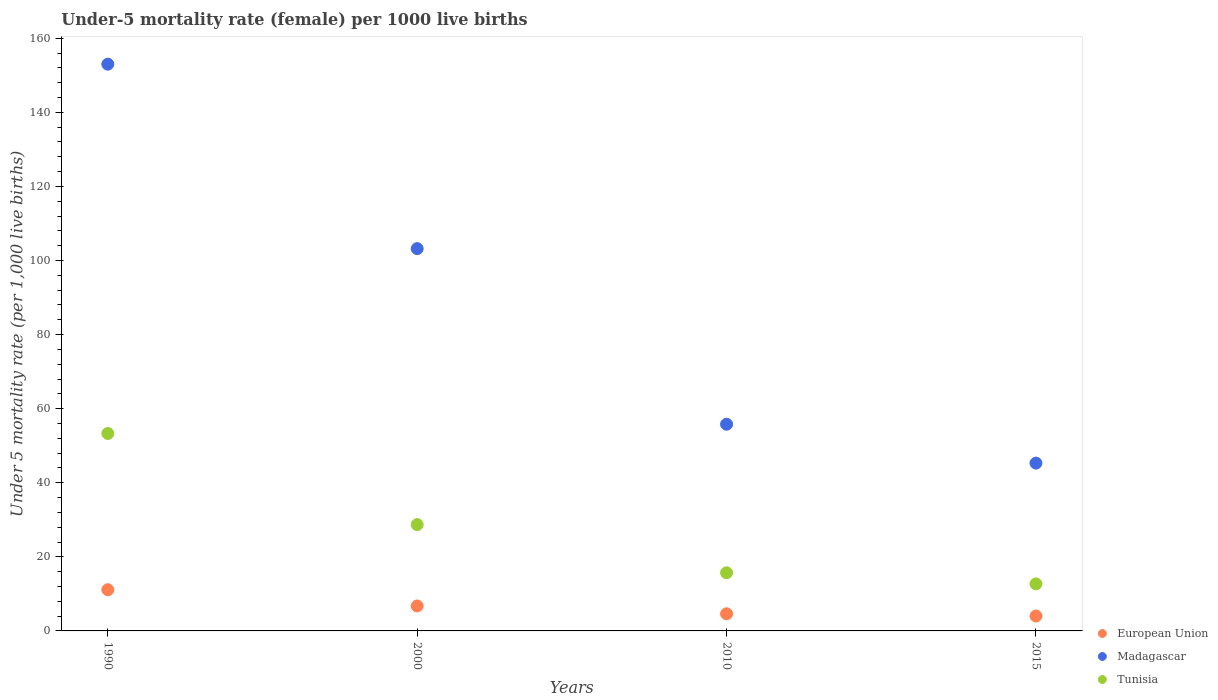What is the under-five mortality rate in Tunisia in 2010?
Offer a very short reply. 15.7. Across all years, what is the maximum under-five mortality rate in Tunisia?
Offer a terse response. 53.3. Across all years, what is the minimum under-five mortality rate in European Union?
Provide a short and direct response. 4.02. In which year was the under-five mortality rate in European Union minimum?
Keep it short and to the point. 2015. What is the total under-five mortality rate in European Union in the graph?
Your answer should be very brief. 26.5. What is the difference between the under-five mortality rate in Tunisia in 2010 and that in 2015?
Your answer should be compact. 3. What is the difference between the under-five mortality rate in European Union in 2000 and the under-five mortality rate in Tunisia in 1990?
Offer a very short reply. -46.57. What is the average under-five mortality rate in European Union per year?
Offer a very short reply. 6.62. In the year 1990, what is the difference between the under-five mortality rate in Madagascar and under-five mortality rate in Tunisia?
Ensure brevity in your answer.  99.7. What is the ratio of the under-five mortality rate in Madagascar in 1990 to that in 2015?
Keep it short and to the point. 3.38. What is the difference between the highest and the second highest under-five mortality rate in Madagascar?
Your answer should be very brief. 49.8. What is the difference between the highest and the lowest under-five mortality rate in Tunisia?
Make the answer very short. 40.6. Is the sum of the under-five mortality rate in Tunisia in 2000 and 2015 greater than the maximum under-five mortality rate in European Union across all years?
Provide a short and direct response. Yes. Is the under-five mortality rate in Madagascar strictly greater than the under-five mortality rate in Tunisia over the years?
Your response must be concise. Yes. How many dotlines are there?
Offer a very short reply. 3. How many years are there in the graph?
Make the answer very short. 4. What is the difference between two consecutive major ticks on the Y-axis?
Offer a very short reply. 20. Does the graph contain any zero values?
Ensure brevity in your answer.  No. Does the graph contain grids?
Your answer should be very brief. No. How many legend labels are there?
Offer a terse response. 3. What is the title of the graph?
Make the answer very short. Under-5 mortality rate (female) per 1000 live births. What is the label or title of the Y-axis?
Provide a succinct answer. Under 5 mortality rate (per 1,0 live births). What is the Under 5 mortality rate (per 1,000 live births) in European Union in 1990?
Offer a very short reply. 11.12. What is the Under 5 mortality rate (per 1,000 live births) in Madagascar in 1990?
Provide a short and direct response. 153. What is the Under 5 mortality rate (per 1,000 live births) of Tunisia in 1990?
Keep it short and to the point. 53.3. What is the Under 5 mortality rate (per 1,000 live births) of European Union in 2000?
Your response must be concise. 6.73. What is the Under 5 mortality rate (per 1,000 live births) in Madagascar in 2000?
Your response must be concise. 103.2. What is the Under 5 mortality rate (per 1,000 live births) of Tunisia in 2000?
Provide a succinct answer. 28.7. What is the Under 5 mortality rate (per 1,000 live births) of European Union in 2010?
Your response must be concise. 4.62. What is the Under 5 mortality rate (per 1,000 live births) in Madagascar in 2010?
Offer a terse response. 55.8. What is the Under 5 mortality rate (per 1,000 live births) of European Union in 2015?
Your response must be concise. 4.02. What is the Under 5 mortality rate (per 1,000 live births) in Madagascar in 2015?
Offer a very short reply. 45.3. Across all years, what is the maximum Under 5 mortality rate (per 1,000 live births) in European Union?
Provide a succinct answer. 11.12. Across all years, what is the maximum Under 5 mortality rate (per 1,000 live births) in Madagascar?
Your response must be concise. 153. Across all years, what is the maximum Under 5 mortality rate (per 1,000 live births) of Tunisia?
Your response must be concise. 53.3. Across all years, what is the minimum Under 5 mortality rate (per 1,000 live births) of European Union?
Ensure brevity in your answer.  4.02. Across all years, what is the minimum Under 5 mortality rate (per 1,000 live births) of Madagascar?
Provide a succinct answer. 45.3. Across all years, what is the minimum Under 5 mortality rate (per 1,000 live births) of Tunisia?
Your answer should be compact. 12.7. What is the total Under 5 mortality rate (per 1,000 live births) in European Union in the graph?
Offer a terse response. 26.5. What is the total Under 5 mortality rate (per 1,000 live births) of Madagascar in the graph?
Make the answer very short. 357.3. What is the total Under 5 mortality rate (per 1,000 live births) in Tunisia in the graph?
Give a very brief answer. 110.4. What is the difference between the Under 5 mortality rate (per 1,000 live births) in European Union in 1990 and that in 2000?
Your answer should be very brief. 4.38. What is the difference between the Under 5 mortality rate (per 1,000 live births) of Madagascar in 1990 and that in 2000?
Give a very brief answer. 49.8. What is the difference between the Under 5 mortality rate (per 1,000 live births) in Tunisia in 1990 and that in 2000?
Provide a succinct answer. 24.6. What is the difference between the Under 5 mortality rate (per 1,000 live births) of European Union in 1990 and that in 2010?
Give a very brief answer. 6.49. What is the difference between the Under 5 mortality rate (per 1,000 live births) of Madagascar in 1990 and that in 2010?
Your answer should be very brief. 97.2. What is the difference between the Under 5 mortality rate (per 1,000 live births) of Tunisia in 1990 and that in 2010?
Offer a very short reply. 37.6. What is the difference between the Under 5 mortality rate (per 1,000 live births) in European Union in 1990 and that in 2015?
Ensure brevity in your answer.  7.1. What is the difference between the Under 5 mortality rate (per 1,000 live births) of Madagascar in 1990 and that in 2015?
Ensure brevity in your answer.  107.7. What is the difference between the Under 5 mortality rate (per 1,000 live births) in Tunisia in 1990 and that in 2015?
Your answer should be compact. 40.6. What is the difference between the Under 5 mortality rate (per 1,000 live births) in European Union in 2000 and that in 2010?
Give a very brief answer. 2.11. What is the difference between the Under 5 mortality rate (per 1,000 live births) in Madagascar in 2000 and that in 2010?
Give a very brief answer. 47.4. What is the difference between the Under 5 mortality rate (per 1,000 live births) of European Union in 2000 and that in 2015?
Offer a very short reply. 2.71. What is the difference between the Under 5 mortality rate (per 1,000 live births) in Madagascar in 2000 and that in 2015?
Your answer should be compact. 57.9. What is the difference between the Under 5 mortality rate (per 1,000 live births) of Tunisia in 2000 and that in 2015?
Give a very brief answer. 16. What is the difference between the Under 5 mortality rate (per 1,000 live births) of European Union in 2010 and that in 2015?
Offer a very short reply. 0.6. What is the difference between the Under 5 mortality rate (per 1,000 live births) of Tunisia in 2010 and that in 2015?
Your response must be concise. 3. What is the difference between the Under 5 mortality rate (per 1,000 live births) in European Union in 1990 and the Under 5 mortality rate (per 1,000 live births) in Madagascar in 2000?
Your answer should be very brief. -92.08. What is the difference between the Under 5 mortality rate (per 1,000 live births) in European Union in 1990 and the Under 5 mortality rate (per 1,000 live births) in Tunisia in 2000?
Your answer should be compact. -17.58. What is the difference between the Under 5 mortality rate (per 1,000 live births) in Madagascar in 1990 and the Under 5 mortality rate (per 1,000 live births) in Tunisia in 2000?
Keep it short and to the point. 124.3. What is the difference between the Under 5 mortality rate (per 1,000 live births) in European Union in 1990 and the Under 5 mortality rate (per 1,000 live births) in Madagascar in 2010?
Your answer should be compact. -44.68. What is the difference between the Under 5 mortality rate (per 1,000 live births) in European Union in 1990 and the Under 5 mortality rate (per 1,000 live births) in Tunisia in 2010?
Give a very brief answer. -4.58. What is the difference between the Under 5 mortality rate (per 1,000 live births) of Madagascar in 1990 and the Under 5 mortality rate (per 1,000 live births) of Tunisia in 2010?
Your answer should be compact. 137.3. What is the difference between the Under 5 mortality rate (per 1,000 live births) of European Union in 1990 and the Under 5 mortality rate (per 1,000 live births) of Madagascar in 2015?
Make the answer very short. -34.18. What is the difference between the Under 5 mortality rate (per 1,000 live births) in European Union in 1990 and the Under 5 mortality rate (per 1,000 live births) in Tunisia in 2015?
Offer a very short reply. -1.58. What is the difference between the Under 5 mortality rate (per 1,000 live births) of Madagascar in 1990 and the Under 5 mortality rate (per 1,000 live births) of Tunisia in 2015?
Your answer should be compact. 140.3. What is the difference between the Under 5 mortality rate (per 1,000 live births) in European Union in 2000 and the Under 5 mortality rate (per 1,000 live births) in Madagascar in 2010?
Ensure brevity in your answer.  -49.07. What is the difference between the Under 5 mortality rate (per 1,000 live births) of European Union in 2000 and the Under 5 mortality rate (per 1,000 live births) of Tunisia in 2010?
Your answer should be compact. -8.97. What is the difference between the Under 5 mortality rate (per 1,000 live births) in Madagascar in 2000 and the Under 5 mortality rate (per 1,000 live births) in Tunisia in 2010?
Make the answer very short. 87.5. What is the difference between the Under 5 mortality rate (per 1,000 live births) in European Union in 2000 and the Under 5 mortality rate (per 1,000 live births) in Madagascar in 2015?
Ensure brevity in your answer.  -38.57. What is the difference between the Under 5 mortality rate (per 1,000 live births) of European Union in 2000 and the Under 5 mortality rate (per 1,000 live births) of Tunisia in 2015?
Your response must be concise. -5.97. What is the difference between the Under 5 mortality rate (per 1,000 live births) of Madagascar in 2000 and the Under 5 mortality rate (per 1,000 live births) of Tunisia in 2015?
Provide a succinct answer. 90.5. What is the difference between the Under 5 mortality rate (per 1,000 live births) in European Union in 2010 and the Under 5 mortality rate (per 1,000 live births) in Madagascar in 2015?
Provide a short and direct response. -40.68. What is the difference between the Under 5 mortality rate (per 1,000 live births) in European Union in 2010 and the Under 5 mortality rate (per 1,000 live births) in Tunisia in 2015?
Your answer should be very brief. -8.08. What is the difference between the Under 5 mortality rate (per 1,000 live births) in Madagascar in 2010 and the Under 5 mortality rate (per 1,000 live births) in Tunisia in 2015?
Provide a succinct answer. 43.1. What is the average Under 5 mortality rate (per 1,000 live births) of European Union per year?
Keep it short and to the point. 6.62. What is the average Under 5 mortality rate (per 1,000 live births) in Madagascar per year?
Your answer should be compact. 89.33. What is the average Under 5 mortality rate (per 1,000 live births) in Tunisia per year?
Give a very brief answer. 27.6. In the year 1990, what is the difference between the Under 5 mortality rate (per 1,000 live births) in European Union and Under 5 mortality rate (per 1,000 live births) in Madagascar?
Your answer should be very brief. -141.88. In the year 1990, what is the difference between the Under 5 mortality rate (per 1,000 live births) of European Union and Under 5 mortality rate (per 1,000 live births) of Tunisia?
Your answer should be very brief. -42.18. In the year 1990, what is the difference between the Under 5 mortality rate (per 1,000 live births) of Madagascar and Under 5 mortality rate (per 1,000 live births) of Tunisia?
Give a very brief answer. 99.7. In the year 2000, what is the difference between the Under 5 mortality rate (per 1,000 live births) of European Union and Under 5 mortality rate (per 1,000 live births) of Madagascar?
Ensure brevity in your answer.  -96.47. In the year 2000, what is the difference between the Under 5 mortality rate (per 1,000 live births) of European Union and Under 5 mortality rate (per 1,000 live births) of Tunisia?
Your answer should be very brief. -21.97. In the year 2000, what is the difference between the Under 5 mortality rate (per 1,000 live births) of Madagascar and Under 5 mortality rate (per 1,000 live births) of Tunisia?
Provide a short and direct response. 74.5. In the year 2010, what is the difference between the Under 5 mortality rate (per 1,000 live births) of European Union and Under 5 mortality rate (per 1,000 live births) of Madagascar?
Your response must be concise. -51.18. In the year 2010, what is the difference between the Under 5 mortality rate (per 1,000 live births) of European Union and Under 5 mortality rate (per 1,000 live births) of Tunisia?
Provide a short and direct response. -11.08. In the year 2010, what is the difference between the Under 5 mortality rate (per 1,000 live births) of Madagascar and Under 5 mortality rate (per 1,000 live births) of Tunisia?
Your answer should be compact. 40.1. In the year 2015, what is the difference between the Under 5 mortality rate (per 1,000 live births) in European Union and Under 5 mortality rate (per 1,000 live births) in Madagascar?
Ensure brevity in your answer.  -41.28. In the year 2015, what is the difference between the Under 5 mortality rate (per 1,000 live births) of European Union and Under 5 mortality rate (per 1,000 live births) of Tunisia?
Offer a very short reply. -8.68. In the year 2015, what is the difference between the Under 5 mortality rate (per 1,000 live births) of Madagascar and Under 5 mortality rate (per 1,000 live births) of Tunisia?
Make the answer very short. 32.6. What is the ratio of the Under 5 mortality rate (per 1,000 live births) of European Union in 1990 to that in 2000?
Offer a terse response. 1.65. What is the ratio of the Under 5 mortality rate (per 1,000 live births) in Madagascar in 1990 to that in 2000?
Offer a terse response. 1.48. What is the ratio of the Under 5 mortality rate (per 1,000 live births) in Tunisia in 1990 to that in 2000?
Your answer should be compact. 1.86. What is the ratio of the Under 5 mortality rate (per 1,000 live births) of European Union in 1990 to that in 2010?
Your answer should be very brief. 2.4. What is the ratio of the Under 5 mortality rate (per 1,000 live births) of Madagascar in 1990 to that in 2010?
Your answer should be compact. 2.74. What is the ratio of the Under 5 mortality rate (per 1,000 live births) of Tunisia in 1990 to that in 2010?
Your answer should be compact. 3.39. What is the ratio of the Under 5 mortality rate (per 1,000 live births) of European Union in 1990 to that in 2015?
Provide a succinct answer. 2.76. What is the ratio of the Under 5 mortality rate (per 1,000 live births) in Madagascar in 1990 to that in 2015?
Your answer should be compact. 3.38. What is the ratio of the Under 5 mortality rate (per 1,000 live births) of Tunisia in 1990 to that in 2015?
Your response must be concise. 4.2. What is the ratio of the Under 5 mortality rate (per 1,000 live births) in European Union in 2000 to that in 2010?
Give a very brief answer. 1.46. What is the ratio of the Under 5 mortality rate (per 1,000 live births) in Madagascar in 2000 to that in 2010?
Provide a short and direct response. 1.85. What is the ratio of the Under 5 mortality rate (per 1,000 live births) in Tunisia in 2000 to that in 2010?
Your answer should be very brief. 1.83. What is the ratio of the Under 5 mortality rate (per 1,000 live births) of European Union in 2000 to that in 2015?
Your answer should be compact. 1.67. What is the ratio of the Under 5 mortality rate (per 1,000 live births) of Madagascar in 2000 to that in 2015?
Give a very brief answer. 2.28. What is the ratio of the Under 5 mortality rate (per 1,000 live births) of Tunisia in 2000 to that in 2015?
Ensure brevity in your answer.  2.26. What is the ratio of the Under 5 mortality rate (per 1,000 live births) of European Union in 2010 to that in 2015?
Provide a succinct answer. 1.15. What is the ratio of the Under 5 mortality rate (per 1,000 live births) of Madagascar in 2010 to that in 2015?
Ensure brevity in your answer.  1.23. What is the ratio of the Under 5 mortality rate (per 1,000 live births) in Tunisia in 2010 to that in 2015?
Provide a succinct answer. 1.24. What is the difference between the highest and the second highest Under 5 mortality rate (per 1,000 live births) in European Union?
Keep it short and to the point. 4.38. What is the difference between the highest and the second highest Under 5 mortality rate (per 1,000 live births) of Madagascar?
Offer a very short reply. 49.8. What is the difference between the highest and the second highest Under 5 mortality rate (per 1,000 live births) in Tunisia?
Provide a succinct answer. 24.6. What is the difference between the highest and the lowest Under 5 mortality rate (per 1,000 live births) of European Union?
Make the answer very short. 7.1. What is the difference between the highest and the lowest Under 5 mortality rate (per 1,000 live births) in Madagascar?
Give a very brief answer. 107.7. What is the difference between the highest and the lowest Under 5 mortality rate (per 1,000 live births) in Tunisia?
Offer a very short reply. 40.6. 